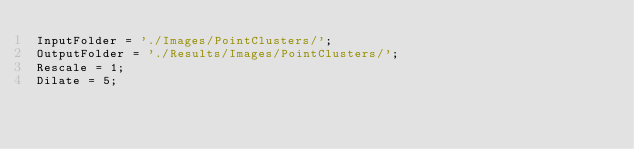Convert code to text. <code><loc_0><loc_0><loc_500><loc_500><_Julia_>InputFolder = './Images/PointClusters/';
OutputFolder = './Results/Images/PointClusters/';
Rescale = 1;
Dilate = 5;</code> 